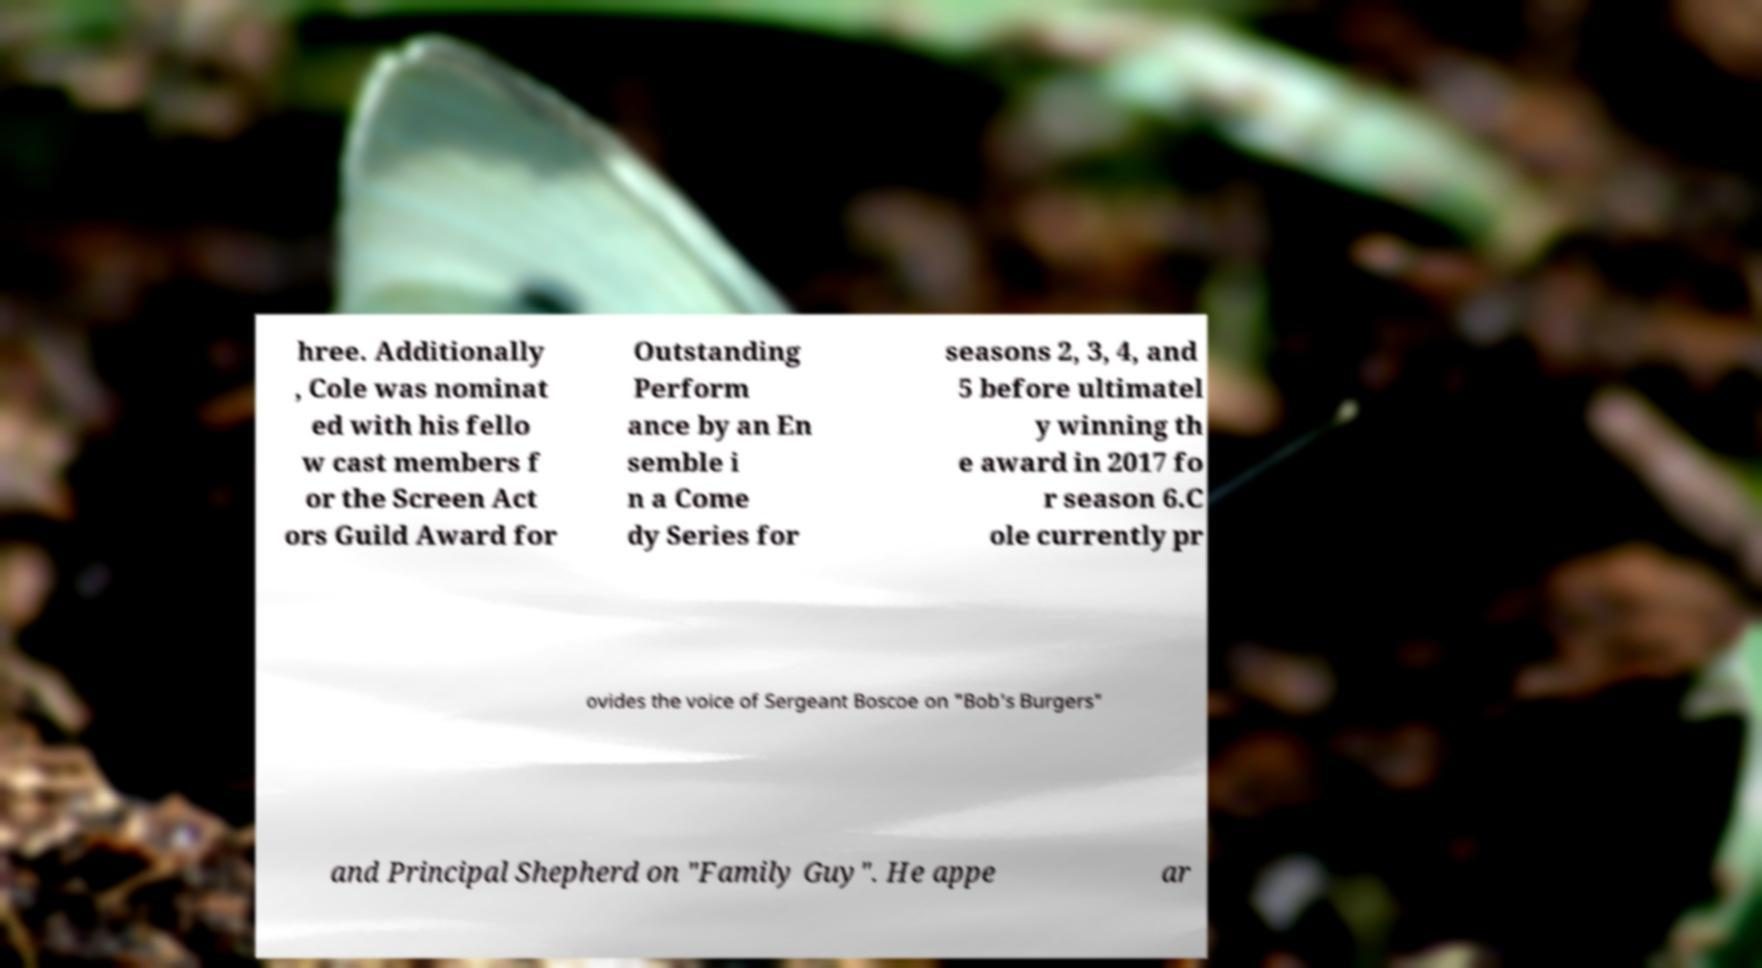What messages or text are displayed in this image? I need them in a readable, typed format. hree. Additionally , Cole was nominat ed with his fello w cast members f or the Screen Act ors Guild Award for Outstanding Perform ance by an En semble i n a Come dy Series for seasons 2, 3, 4, and 5 before ultimatel y winning th e award in 2017 fo r season 6.C ole currently pr ovides the voice of Sergeant Boscoe on "Bob's Burgers" and Principal Shepherd on "Family Guy". He appe ar 